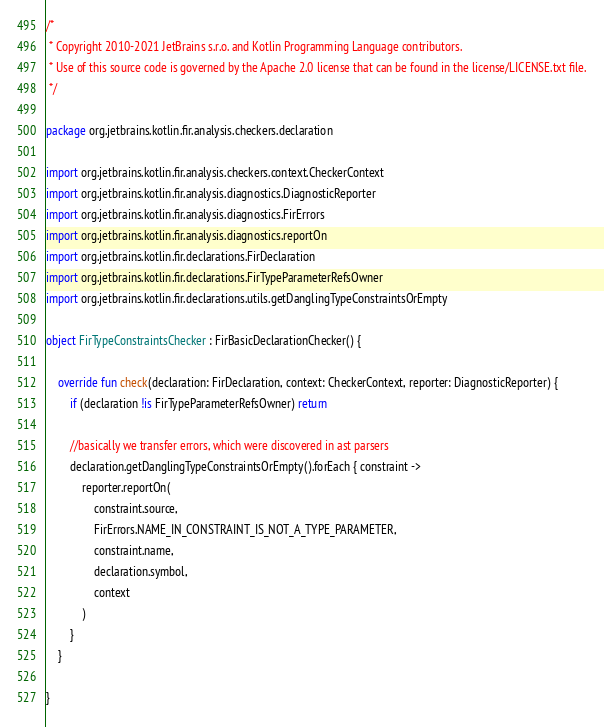Convert code to text. <code><loc_0><loc_0><loc_500><loc_500><_Kotlin_>/*
 * Copyright 2010-2021 JetBrains s.r.o. and Kotlin Programming Language contributors.
 * Use of this source code is governed by the Apache 2.0 license that can be found in the license/LICENSE.txt file.
 */

package org.jetbrains.kotlin.fir.analysis.checkers.declaration

import org.jetbrains.kotlin.fir.analysis.checkers.context.CheckerContext
import org.jetbrains.kotlin.fir.analysis.diagnostics.DiagnosticReporter
import org.jetbrains.kotlin.fir.analysis.diagnostics.FirErrors
import org.jetbrains.kotlin.fir.analysis.diagnostics.reportOn
import org.jetbrains.kotlin.fir.declarations.FirDeclaration
import org.jetbrains.kotlin.fir.declarations.FirTypeParameterRefsOwner
import org.jetbrains.kotlin.fir.declarations.utils.getDanglingTypeConstraintsOrEmpty

object FirTypeConstraintsChecker : FirBasicDeclarationChecker() {

    override fun check(declaration: FirDeclaration, context: CheckerContext, reporter: DiagnosticReporter) {
        if (declaration !is FirTypeParameterRefsOwner) return

        //basically we transfer errors, which were discovered in ast parsers
        declaration.getDanglingTypeConstraintsOrEmpty().forEach { constraint ->
            reporter.reportOn(
                constraint.source,
                FirErrors.NAME_IN_CONSTRAINT_IS_NOT_A_TYPE_PARAMETER,
                constraint.name,
                declaration.symbol,
                context
            )
        }
    }

}
</code> 